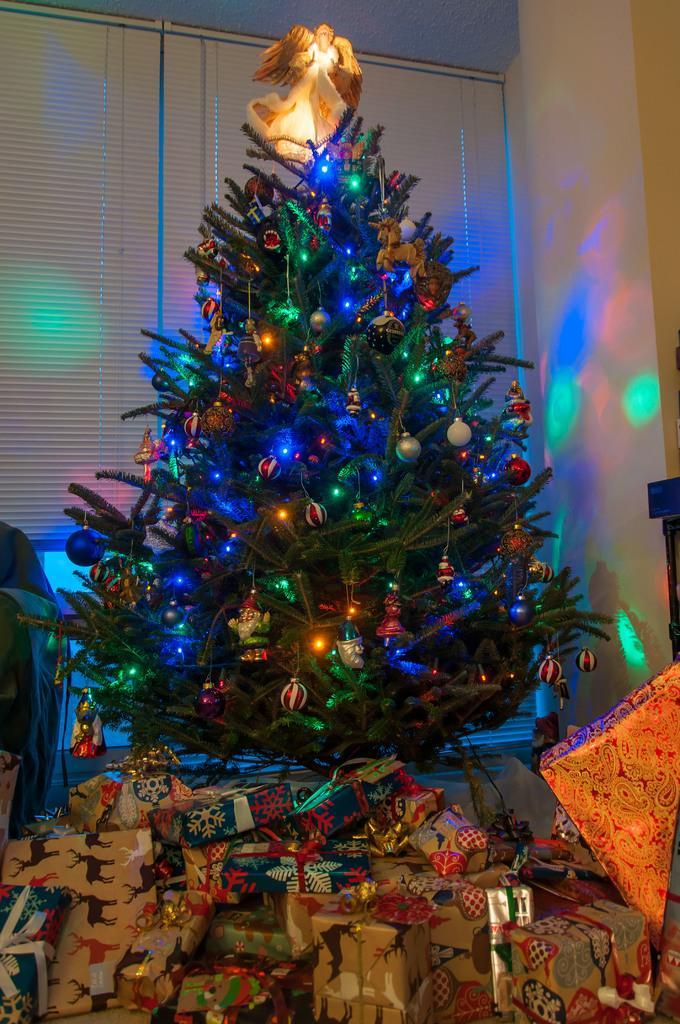Describe this image in one or two sentences. In this image there is a Christmas tree. Above the tree there is a fairy doll. On the tree there are many decorative things. Below the tree there are many gift boxes. There are fairy lights on the tree. To the right there is a wall. Behind the tree there are window blinds. 